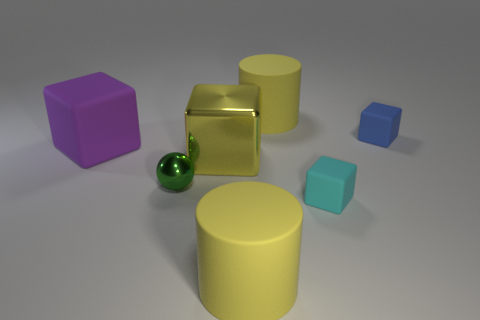Are the big yellow object behind the yellow cube and the tiny block that is behind the small cyan rubber object made of the same material?
Your answer should be very brief. Yes. There is a blue matte thing that is the same size as the cyan object; what shape is it?
Give a very brief answer. Cube. Is the number of tiny cubes less than the number of gray matte objects?
Your answer should be very brief. No. There is a matte cylinder that is behind the cyan rubber thing; is there a yellow rubber cylinder that is in front of it?
Provide a short and direct response. Yes. Is there a block to the right of the small cyan thing to the right of the tiny green shiny thing in front of the big purple rubber block?
Give a very brief answer. Yes. Do the cyan matte object that is to the right of the big yellow shiny thing and the object left of the tiny metal object have the same shape?
Provide a short and direct response. Yes. What is the color of the tiny block that is the same material as the cyan object?
Keep it short and to the point. Blue. Is the number of small cyan rubber things that are behind the tiny cyan cube less than the number of small cyan matte cylinders?
Make the answer very short. No. What size is the matte object to the left of the big yellow thing in front of the rubber block in front of the shiny ball?
Keep it short and to the point. Large. Do the block in front of the large metal object and the sphere have the same material?
Provide a succinct answer. No. 